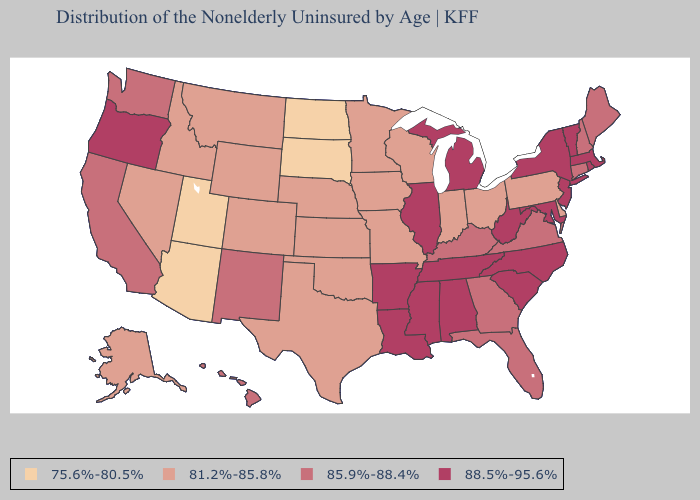Does the map have missing data?
Write a very short answer. No. Does New Jersey have the highest value in the Northeast?
Keep it brief. Yes. Among the states that border Minnesota , which have the highest value?
Quick response, please. Iowa, Wisconsin. What is the value of Rhode Island?
Be succinct. 88.5%-95.6%. Name the states that have a value in the range 88.5%-95.6%?
Write a very short answer. Alabama, Arkansas, Illinois, Louisiana, Maryland, Massachusetts, Michigan, Mississippi, New Jersey, New York, North Carolina, Oregon, Rhode Island, South Carolina, Tennessee, Vermont, West Virginia. What is the lowest value in the MidWest?
Short answer required. 75.6%-80.5%. What is the value of North Dakota?
Quick response, please. 75.6%-80.5%. What is the value of Utah?
Write a very short answer. 75.6%-80.5%. What is the value of Michigan?
Concise answer only. 88.5%-95.6%. Is the legend a continuous bar?
Answer briefly. No. How many symbols are there in the legend?
Write a very short answer. 4. Does Missouri have the same value as Wisconsin?
Short answer required. Yes. Does the first symbol in the legend represent the smallest category?
Short answer required. Yes. Name the states that have a value in the range 85.9%-88.4%?
Short answer required. California, Connecticut, Florida, Georgia, Hawaii, Kentucky, Maine, New Hampshire, New Mexico, Virginia, Washington. Does New York have the lowest value in the Northeast?
Quick response, please. No. 